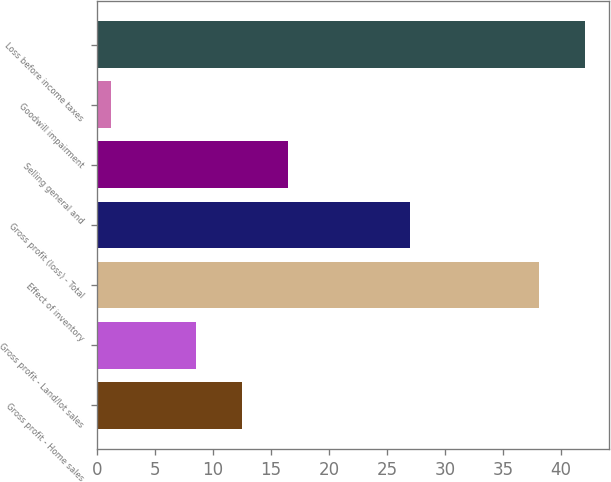Convert chart to OTSL. <chart><loc_0><loc_0><loc_500><loc_500><bar_chart><fcel>Gross profit - Home sales<fcel>Gross profit - Land/lot sales<fcel>Effect of inventory<fcel>Gross profit (loss) - Total<fcel>Selling general and<fcel>Goodwill impairment<fcel>Loss before income taxes<nl><fcel>12.47<fcel>8.5<fcel>38.1<fcel>27<fcel>16.44<fcel>1.2<fcel>42.07<nl></chart> 